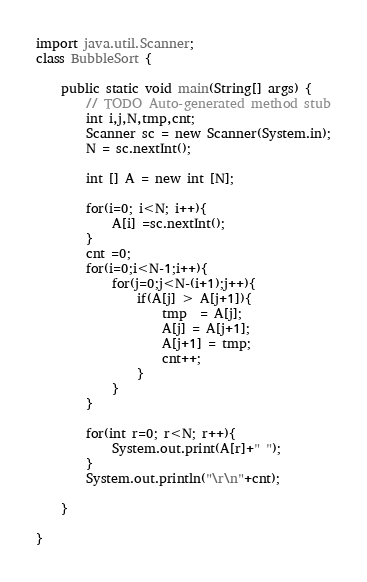<code> <loc_0><loc_0><loc_500><loc_500><_Java_>import java.util.Scanner;
class BubbleSort {

	public static void main(String[] args) {
		// TODO Auto-generated method stub
		int i,j,N,tmp,cnt;
		Scanner sc = new Scanner(System.in);
		N = sc.nextInt();
	
		int [] A = new int [N];
		
		for(i=0; i<N; i++){
			A[i] =sc.nextInt();
		}
		cnt =0;
		for(i=0;i<N-1;i++){
			for(j=0;j<N-(i+1);j++){
				if(A[j] > A[j+1]){
					tmp  = A[j];
					A[j] = A[j+1];
					A[j+1] = tmp;
					cnt++;
				}
			}
		}
		
		for(int r=0; r<N; r++){
			System.out.print(A[r]+" ");
		}
		System.out.println("\r\n"+cnt);

	}

}
</code> 